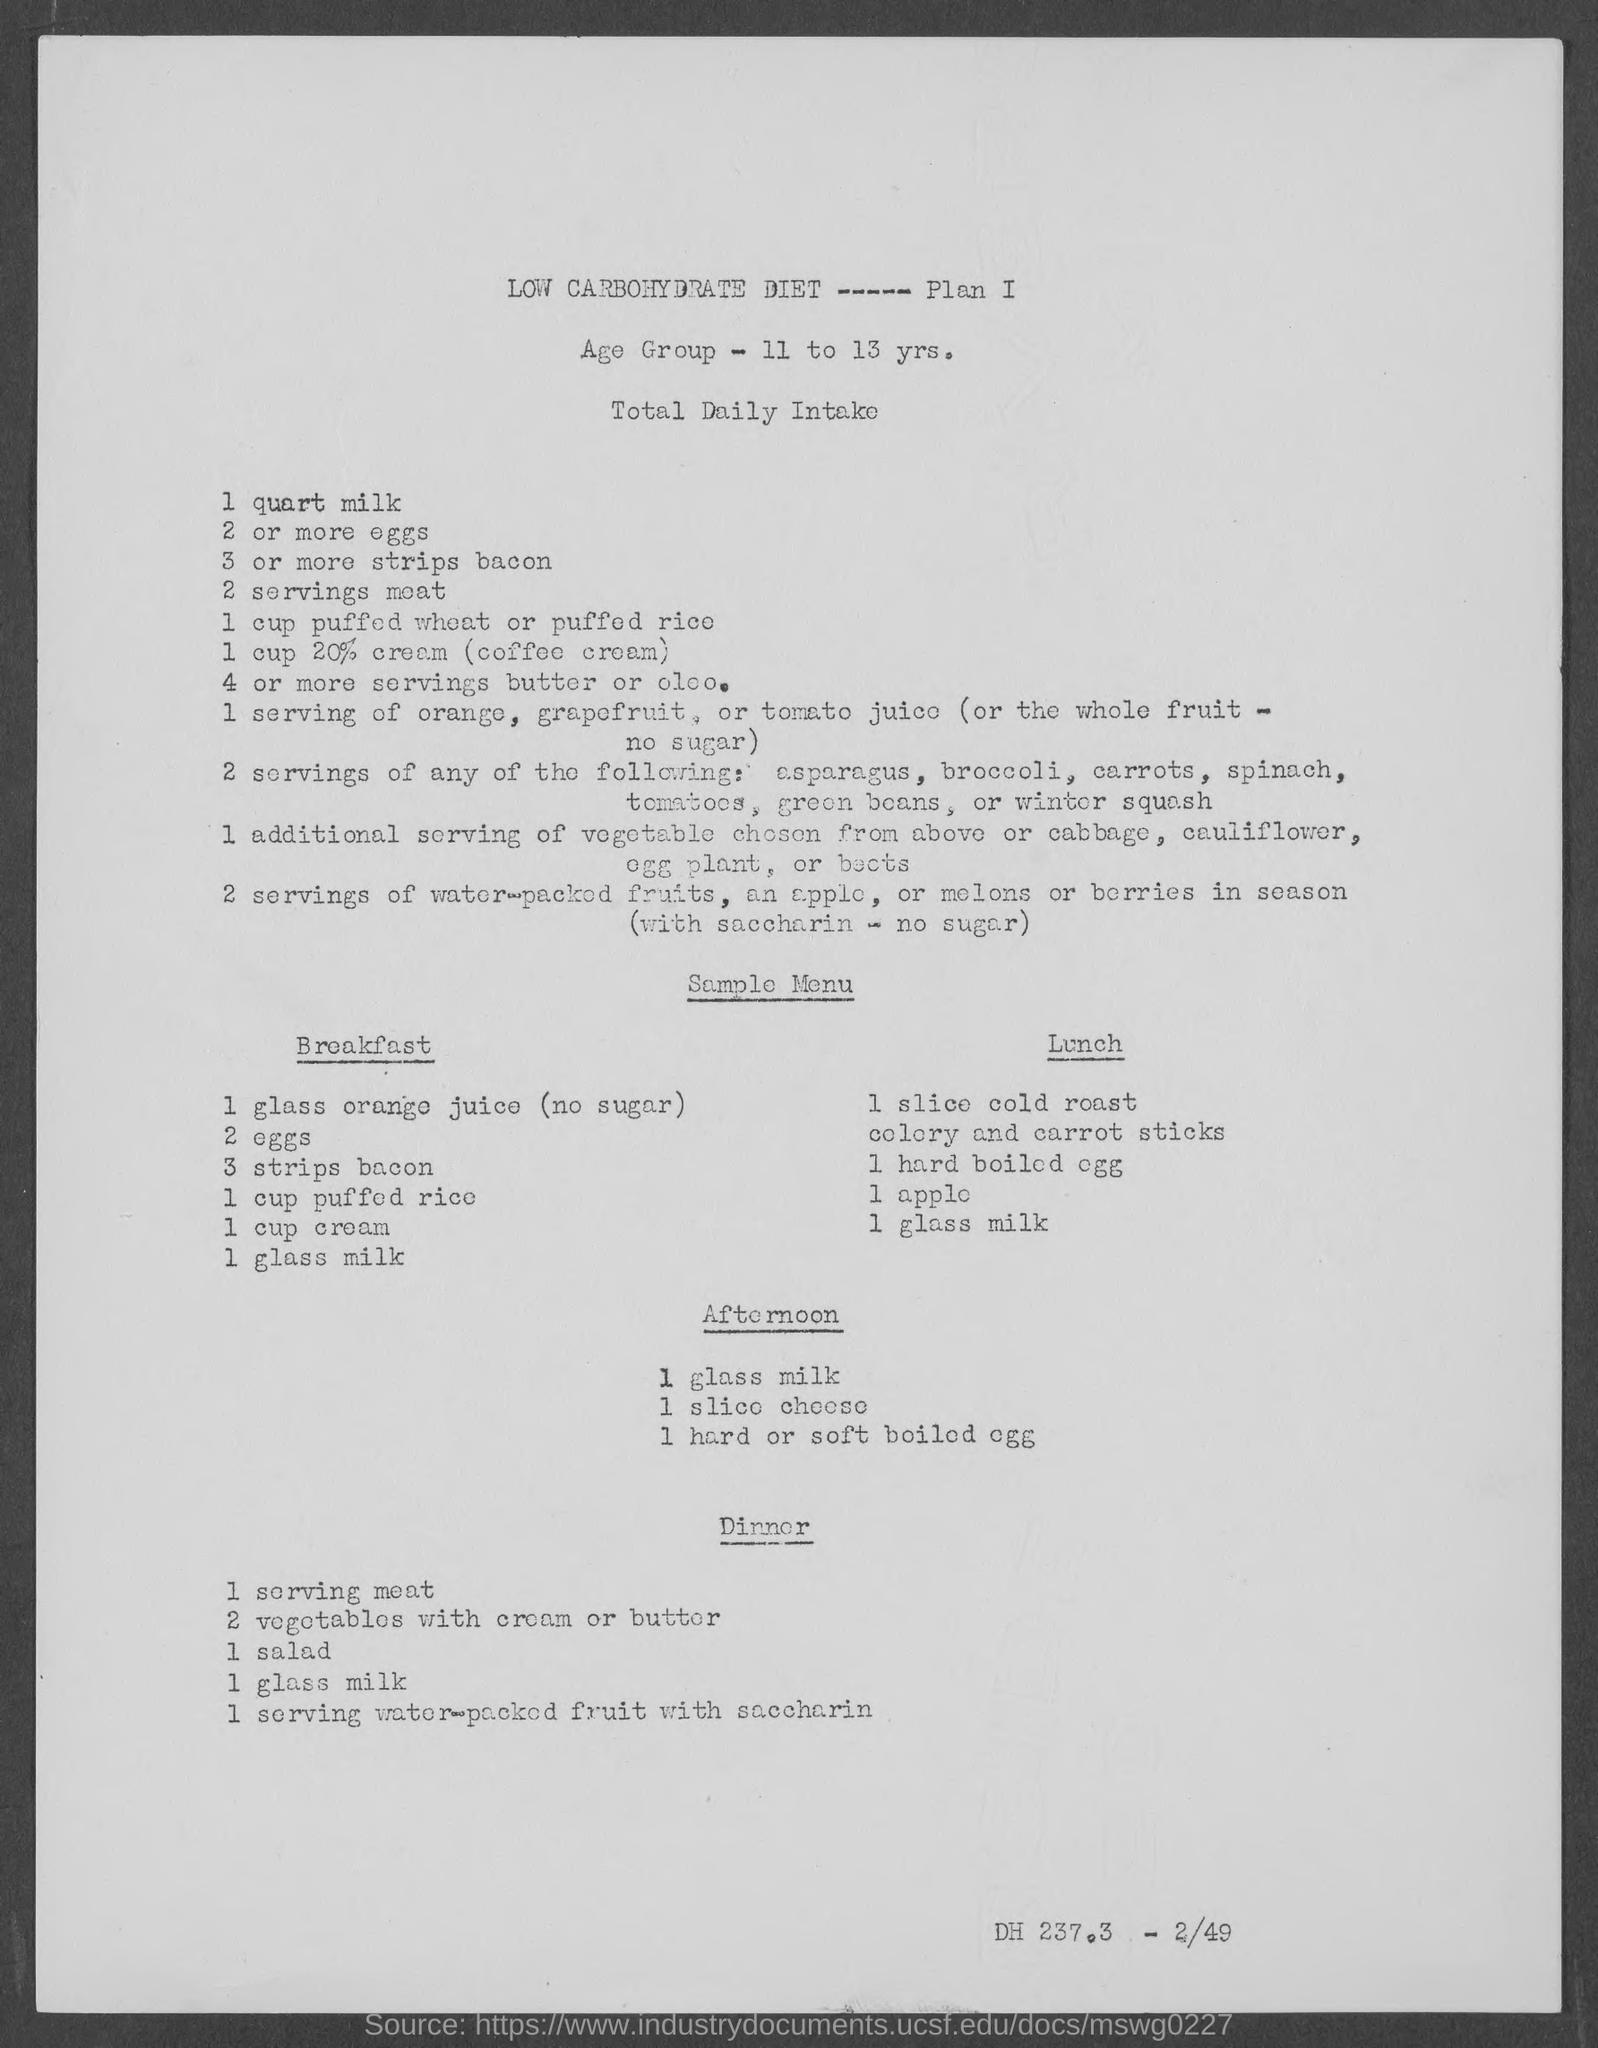What is the Age Group?
Offer a very short reply. 11 to 13 yrs. What is the Total Daily Intake of eggs?
Provide a short and direct response. 2 or more. 